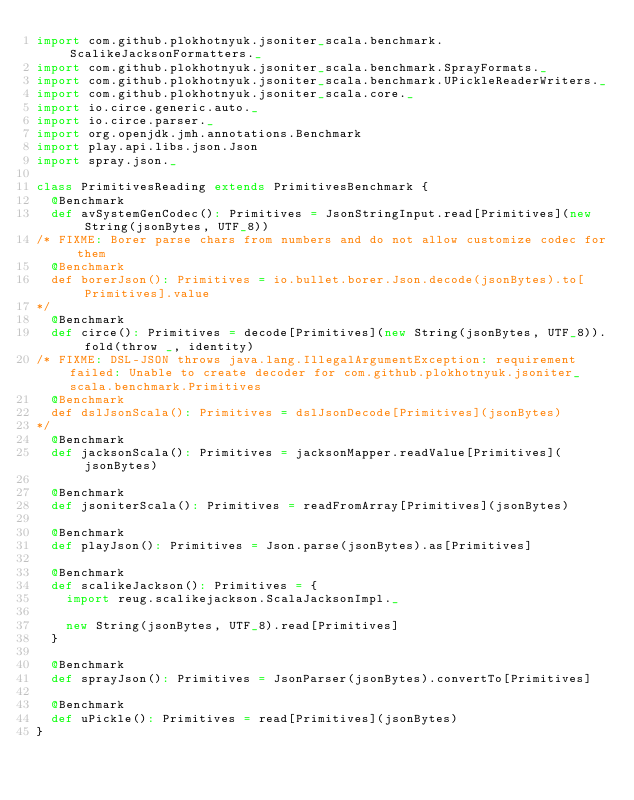<code> <loc_0><loc_0><loc_500><loc_500><_Scala_>import com.github.plokhotnyuk.jsoniter_scala.benchmark.ScalikeJacksonFormatters._
import com.github.plokhotnyuk.jsoniter_scala.benchmark.SprayFormats._
import com.github.plokhotnyuk.jsoniter_scala.benchmark.UPickleReaderWriters._
import com.github.plokhotnyuk.jsoniter_scala.core._
import io.circe.generic.auto._
import io.circe.parser._
import org.openjdk.jmh.annotations.Benchmark
import play.api.libs.json.Json
import spray.json._

class PrimitivesReading extends PrimitivesBenchmark {
  @Benchmark
  def avSystemGenCodec(): Primitives = JsonStringInput.read[Primitives](new String(jsonBytes, UTF_8))
/* FIXME: Borer parse chars from numbers and do not allow customize codec for them
  @Benchmark
  def borerJson(): Primitives = io.bullet.borer.Json.decode(jsonBytes).to[Primitives].value
*/
  @Benchmark
  def circe(): Primitives = decode[Primitives](new String(jsonBytes, UTF_8)).fold(throw _, identity)
/* FIXME: DSL-JSON throws java.lang.IllegalArgumentException: requirement failed: Unable to create decoder for com.github.plokhotnyuk.jsoniter_scala.benchmark.Primitives
  @Benchmark
  def dslJsonScala(): Primitives = dslJsonDecode[Primitives](jsonBytes)
*/
  @Benchmark
  def jacksonScala(): Primitives = jacksonMapper.readValue[Primitives](jsonBytes)

  @Benchmark
  def jsoniterScala(): Primitives = readFromArray[Primitives](jsonBytes)

  @Benchmark
  def playJson(): Primitives = Json.parse(jsonBytes).as[Primitives]

  @Benchmark
  def scalikeJackson(): Primitives = {
    import reug.scalikejackson.ScalaJacksonImpl._

    new String(jsonBytes, UTF_8).read[Primitives]
  }

  @Benchmark
  def sprayJson(): Primitives = JsonParser(jsonBytes).convertTo[Primitives]

  @Benchmark
  def uPickle(): Primitives = read[Primitives](jsonBytes)
}</code> 